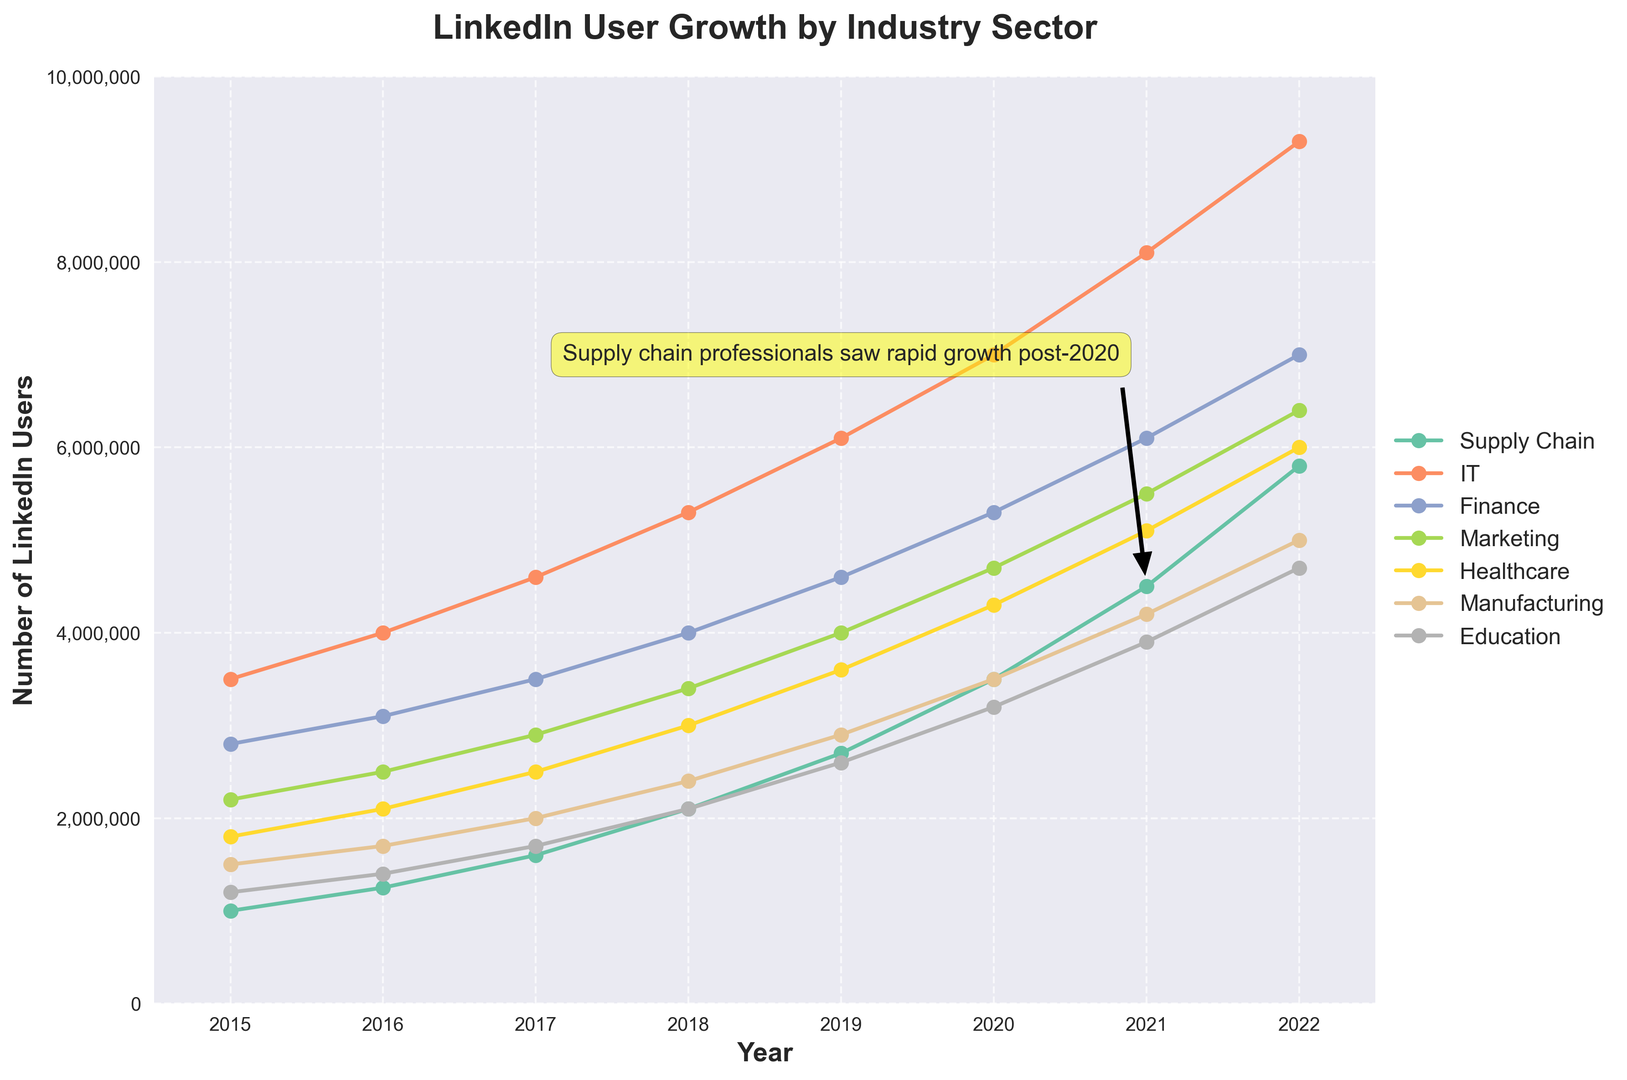What is the annotation text on the chart? The annotation text is a direct label on the chart. It reads: "Supply chain professionals saw rapid growth post-2020"
Answer: Supply chain professionals saw rapid growth post-2020 Which industry had the highest number of LinkedIn users in 2022? To find the highest number of LinkedIn users in 2022, look at the end of the graph for each industry. IT shows 9,300,000 users, which is the highest.
Answer: IT How many more LinkedIn users did the Supply Chain industry have in 2022 compared to 2018? Check the number of users for Supply Chain in 2022 (5,800,000) and in 2018 (2,100,000). The difference is 5,800,000 - 2,100,000 = 3,700,000.
Answer: 3,700,000 Which two industries had the closest number of LinkedIn users in 2019? Compare the number of users in 2019 for all industries. Healthcare and Finance had 3,600,000 and 4,600,000 users respectively. The smallest gap is 400,000 between these two.
Answer: Healthcare and Finance By how many users did Marketing grow from 2015 to 2017? Look at the user numbers for Marketing in both years: 2015 (2,200,000) and 2017 (2,900,000). The growth is 2,900,000 - 2,200,000 = 700,000.
Answer: 700,000 What was the trend for the Education sector from 2016 to 2020? Review the data for Education from 2016 to 2020: 1,400,000 in 2016 to 3,200,000 in 2020. The trend shows steady growth.
Answer: Steady growth Between which two consecutive years did Manufacturing see its highest increase in LinkedIn users? Look at the yearly user numbers for Manufacturing. The biggest jump is between 2018 (2,400,000) and 2019 (2,900,000), an increase of 500,000 users.
Answer: 2018-2019 What is the average number of LinkedIn users for the Healthcare industry from 2015 to 2018? Sum up the user numbers for Healthcare in these years: 1,800,000 + 2,100,000 + 2,500,000 + 3,000,000 = 9,400,000. Then, divide by 4 (years): 9,400,000 / 4 = 2,350,000.
Answer: 2,350,000 What was the absolute growth in LinkedIn users for IT from 2015 to 2022? Check the user numbers for IT in 2015 (3,500,000) and 2022 (9,300,000). The absolute growth is 9,300,000 - 3,500,000 = 5,800,000.
Answer: 5,800,000 